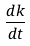<formula> <loc_0><loc_0><loc_500><loc_500>\frac { d k } { d t }</formula> 